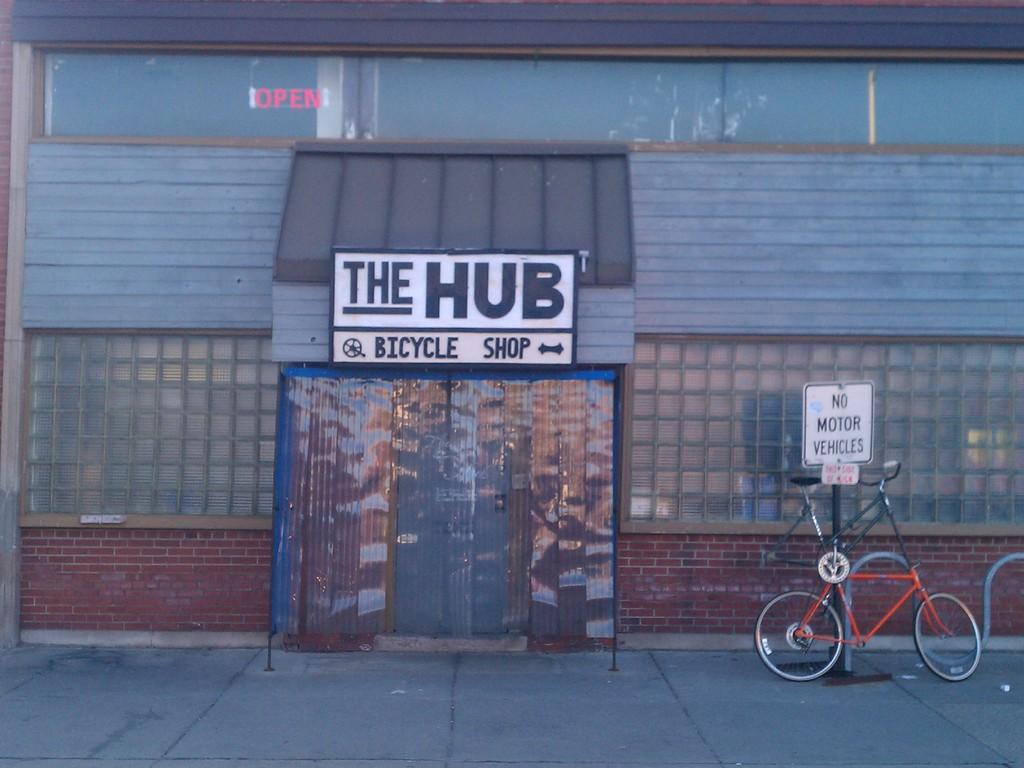What is the main structure visible in the image? There is a building in the image. What can be seen in front of the building? There is a bicycle and a pole in front of the building. What type of grain is being harvested in the image? There is no grain or harvesting activity present in the image; it features a building, a bicycle, and a pole. 